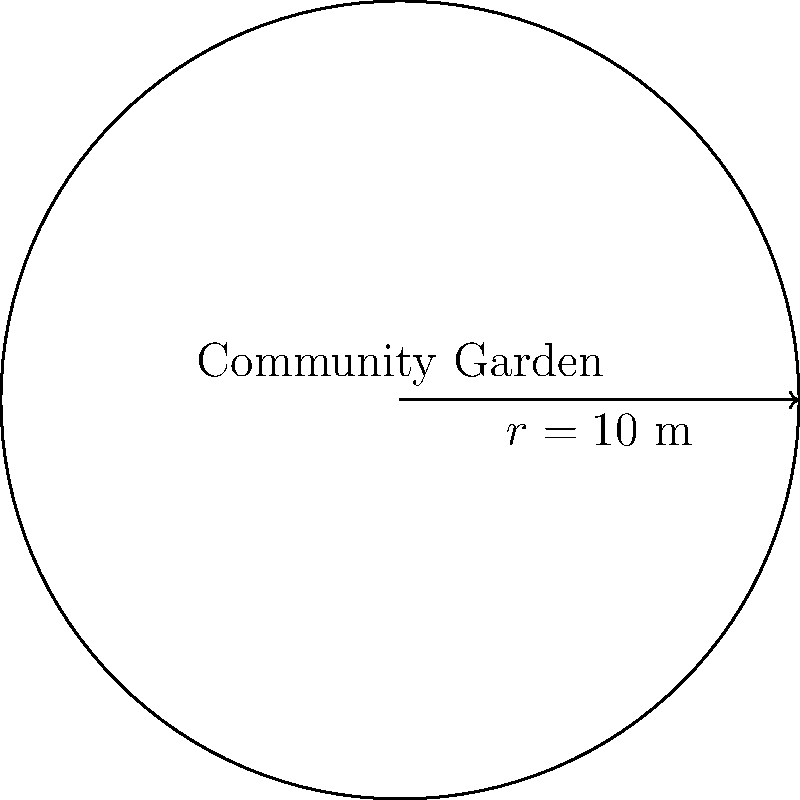As part of a local business promotion initiative, you're helping design a circular community garden plot. If the radius of the garden is 10 meters, what is the area of the garden plot? (Use $\pi \approx 3.14$ and round your answer to the nearest square meter.) To find the area of a circular garden plot, we can follow these steps:

1) The formula for the area of a circle is $A = \pi r^2$, where $r$ is the radius.

2) We're given that the radius is 10 meters and we should use $\pi \approx 3.14$.

3) Let's substitute these values into the formula:
   $A = 3.14 \times 10^2$

4) Simplify:
   $A = 3.14 \times 100 = 314$

5) The question asks to round to the nearest square meter, but 314 is already a whole number.

Therefore, the area of the community garden plot is 314 square meters.
Answer: 314 m² 